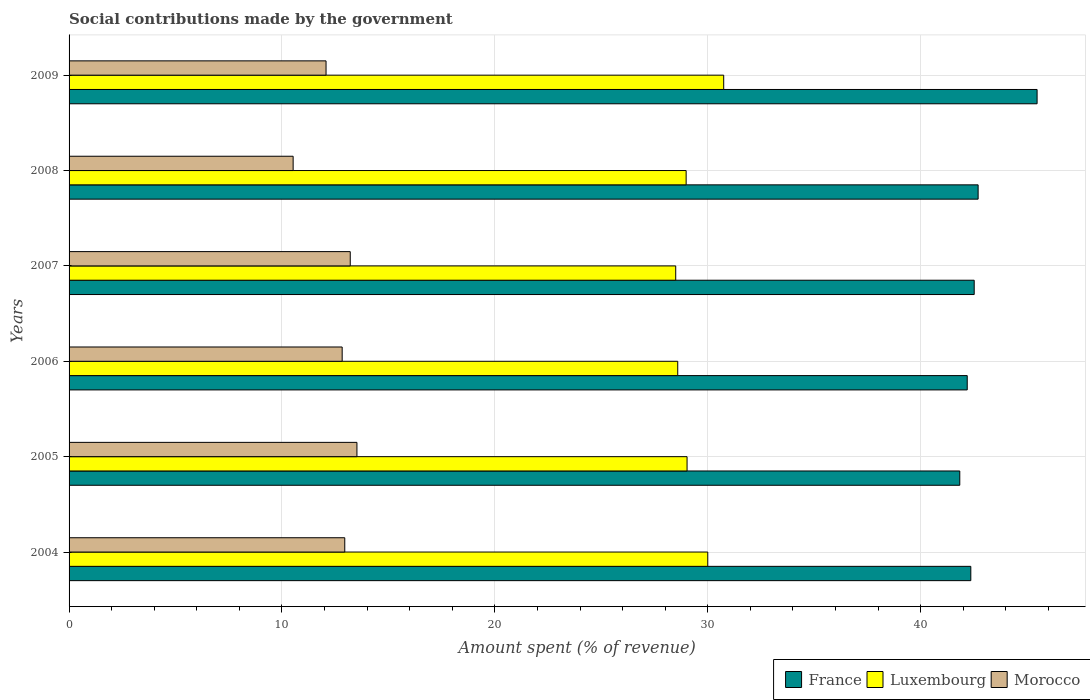How many groups of bars are there?
Offer a terse response. 6. How many bars are there on the 3rd tick from the top?
Make the answer very short. 3. What is the amount spent (in %) on social contributions in France in 2005?
Your answer should be very brief. 41.83. Across all years, what is the maximum amount spent (in %) on social contributions in Morocco?
Provide a short and direct response. 13.52. Across all years, what is the minimum amount spent (in %) on social contributions in Morocco?
Your response must be concise. 10.52. In which year was the amount spent (in %) on social contributions in Luxembourg maximum?
Provide a succinct answer. 2009. What is the total amount spent (in %) on social contributions in France in the graph?
Your answer should be compact. 257.04. What is the difference between the amount spent (in %) on social contributions in France in 2004 and that in 2009?
Ensure brevity in your answer.  -3.11. What is the difference between the amount spent (in %) on social contributions in Luxembourg in 2005 and the amount spent (in %) on social contributions in France in 2008?
Give a very brief answer. -13.67. What is the average amount spent (in %) on social contributions in Luxembourg per year?
Your response must be concise. 29.3. In the year 2006, what is the difference between the amount spent (in %) on social contributions in France and amount spent (in %) on social contributions in Morocco?
Offer a very short reply. 29.36. In how many years, is the amount spent (in %) on social contributions in France greater than 24 %?
Your answer should be compact. 6. What is the ratio of the amount spent (in %) on social contributions in Luxembourg in 2006 to that in 2008?
Offer a terse response. 0.99. Is the difference between the amount spent (in %) on social contributions in France in 2004 and 2008 greater than the difference between the amount spent (in %) on social contributions in Morocco in 2004 and 2008?
Your answer should be very brief. No. What is the difference between the highest and the second highest amount spent (in %) on social contributions in Morocco?
Your answer should be very brief. 0.31. What is the difference between the highest and the lowest amount spent (in %) on social contributions in France?
Ensure brevity in your answer.  3.63. In how many years, is the amount spent (in %) on social contributions in Luxembourg greater than the average amount spent (in %) on social contributions in Luxembourg taken over all years?
Provide a succinct answer. 2. What does the 3rd bar from the top in 2007 represents?
Make the answer very short. France. Are all the bars in the graph horizontal?
Keep it short and to the point. Yes. How many years are there in the graph?
Ensure brevity in your answer.  6. Are the values on the major ticks of X-axis written in scientific E-notation?
Your response must be concise. No. Does the graph contain grids?
Provide a succinct answer. Yes. How many legend labels are there?
Make the answer very short. 3. What is the title of the graph?
Offer a very short reply. Social contributions made by the government. What is the label or title of the X-axis?
Your answer should be very brief. Amount spent (% of revenue). What is the label or title of the Y-axis?
Keep it short and to the point. Years. What is the Amount spent (% of revenue) of France in 2004?
Your response must be concise. 42.35. What is the Amount spent (% of revenue) in Luxembourg in 2004?
Your response must be concise. 30. What is the Amount spent (% of revenue) of Morocco in 2004?
Ensure brevity in your answer.  12.95. What is the Amount spent (% of revenue) of France in 2005?
Your answer should be very brief. 41.83. What is the Amount spent (% of revenue) in Luxembourg in 2005?
Keep it short and to the point. 29.03. What is the Amount spent (% of revenue) in Morocco in 2005?
Give a very brief answer. 13.52. What is the Amount spent (% of revenue) in France in 2006?
Your response must be concise. 42.18. What is the Amount spent (% of revenue) in Luxembourg in 2006?
Your answer should be compact. 28.59. What is the Amount spent (% of revenue) in Morocco in 2006?
Offer a very short reply. 12.83. What is the Amount spent (% of revenue) in France in 2007?
Offer a terse response. 42.51. What is the Amount spent (% of revenue) of Luxembourg in 2007?
Give a very brief answer. 28.49. What is the Amount spent (% of revenue) of Morocco in 2007?
Your answer should be very brief. 13.21. What is the Amount spent (% of revenue) in France in 2008?
Your response must be concise. 42.7. What is the Amount spent (% of revenue) of Luxembourg in 2008?
Keep it short and to the point. 28.98. What is the Amount spent (% of revenue) in Morocco in 2008?
Ensure brevity in your answer.  10.52. What is the Amount spent (% of revenue) of France in 2009?
Provide a succinct answer. 45.46. What is the Amount spent (% of revenue) of Luxembourg in 2009?
Offer a terse response. 30.75. What is the Amount spent (% of revenue) in Morocco in 2009?
Keep it short and to the point. 12.07. Across all years, what is the maximum Amount spent (% of revenue) of France?
Give a very brief answer. 45.46. Across all years, what is the maximum Amount spent (% of revenue) in Luxembourg?
Give a very brief answer. 30.75. Across all years, what is the maximum Amount spent (% of revenue) of Morocco?
Offer a terse response. 13.52. Across all years, what is the minimum Amount spent (% of revenue) of France?
Offer a very short reply. 41.83. Across all years, what is the minimum Amount spent (% of revenue) of Luxembourg?
Offer a very short reply. 28.49. Across all years, what is the minimum Amount spent (% of revenue) of Morocco?
Your response must be concise. 10.52. What is the total Amount spent (% of revenue) in France in the graph?
Ensure brevity in your answer.  257.04. What is the total Amount spent (% of revenue) of Luxembourg in the graph?
Your answer should be very brief. 175.83. What is the total Amount spent (% of revenue) of Morocco in the graph?
Provide a short and direct response. 75.09. What is the difference between the Amount spent (% of revenue) of France in 2004 and that in 2005?
Keep it short and to the point. 0.52. What is the difference between the Amount spent (% of revenue) in Morocco in 2004 and that in 2005?
Provide a short and direct response. -0.57. What is the difference between the Amount spent (% of revenue) in France in 2004 and that in 2006?
Your response must be concise. 0.17. What is the difference between the Amount spent (% of revenue) in Luxembourg in 2004 and that in 2006?
Your answer should be very brief. 1.41. What is the difference between the Amount spent (% of revenue) in Morocco in 2004 and that in 2006?
Ensure brevity in your answer.  0.12. What is the difference between the Amount spent (% of revenue) in France in 2004 and that in 2007?
Make the answer very short. -0.16. What is the difference between the Amount spent (% of revenue) of Luxembourg in 2004 and that in 2007?
Your response must be concise. 1.5. What is the difference between the Amount spent (% of revenue) of Morocco in 2004 and that in 2007?
Offer a very short reply. -0.26. What is the difference between the Amount spent (% of revenue) of France in 2004 and that in 2008?
Your answer should be very brief. -0.34. What is the difference between the Amount spent (% of revenue) of Luxembourg in 2004 and that in 2008?
Offer a terse response. 1.02. What is the difference between the Amount spent (% of revenue) in Morocco in 2004 and that in 2008?
Offer a very short reply. 2.42. What is the difference between the Amount spent (% of revenue) of France in 2004 and that in 2009?
Ensure brevity in your answer.  -3.11. What is the difference between the Amount spent (% of revenue) of Luxembourg in 2004 and that in 2009?
Provide a short and direct response. -0.75. What is the difference between the Amount spent (% of revenue) of Morocco in 2004 and that in 2009?
Offer a terse response. 0.88. What is the difference between the Amount spent (% of revenue) in France in 2005 and that in 2006?
Your response must be concise. -0.35. What is the difference between the Amount spent (% of revenue) in Luxembourg in 2005 and that in 2006?
Offer a very short reply. 0.44. What is the difference between the Amount spent (% of revenue) of Morocco in 2005 and that in 2006?
Offer a terse response. 0.69. What is the difference between the Amount spent (% of revenue) of France in 2005 and that in 2007?
Your response must be concise. -0.68. What is the difference between the Amount spent (% of revenue) of Luxembourg in 2005 and that in 2007?
Your answer should be very brief. 0.53. What is the difference between the Amount spent (% of revenue) in Morocco in 2005 and that in 2007?
Keep it short and to the point. 0.31. What is the difference between the Amount spent (% of revenue) in France in 2005 and that in 2008?
Provide a succinct answer. -0.86. What is the difference between the Amount spent (% of revenue) of Luxembourg in 2005 and that in 2008?
Ensure brevity in your answer.  0.04. What is the difference between the Amount spent (% of revenue) in Morocco in 2005 and that in 2008?
Provide a short and direct response. 3. What is the difference between the Amount spent (% of revenue) in France in 2005 and that in 2009?
Provide a short and direct response. -3.63. What is the difference between the Amount spent (% of revenue) of Luxembourg in 2005 and that in 2009?
Your answer should be compact. -1.72. What is the difference between the Amount spent (% of revenue) in Morocco in 2005 and that in 2009?
Keep it short and to the point. 1.45. What is the difference between the Amount spent (% of revenue) of France in 2006 and that in 2007?
Offer a very short reply. -0.33. What is the difference between the Amount spent (% of revenue) of Luxembourg in 2006 and that in 2007?
Give a very brief answer. 0.09. What is the difference between the Amount spent (% of revenue) in Morocco in 2006 and that in 2007?
Give a very brief answer. -0.38. What is the difference between the Amount spent (% of revenue) of France in 2006 and that in 2008?
Make the answer very short. -0.51. What is the difference between the Amount spent (% of revenue) in Luxembourg in 2006 and that in 2008?
Offer a terse response. -0.4. What is the difference between the Amount spent (% of revenue) in Morocco in 2006 and that in 2008?
Provide a short and direct response. 2.3. What is the difference between the Amount spent (% of revenue) in France in 2006 and that in 2009?
Your response must be concise. -3.28. What is the difference between the Amount spent (% of revenue) in Luxembourg in 2006 and that in 2009?
Ensure brevity in your answer.  -2.16. What is the difference between the Amount spent (% of revenue) in Morocco in 2006 and that in 2009?
Ensure brevity in your answer.  0.76. What is the difference between the Amount spent (% of revenue) of France in 2007 and that in 2008?
Keep it short and to the point. -0.18. What is the difference between the Amount spent (% of revenue) of Luxembourg in 2007 and that in 2008?
Your answer should be very brief. -0.49. What is the difference between the Amount spent (% of revenue) in Morocco in 2007 and that in 2008?
Offer a very short reply. 2.68. What is the difference between the Amount spent (% of revenue) in France in 2007 and that in 2009?
Give a very brief answer. -2.95. What is the difference between the Amount spent (% of revenue) of Luxembourg in 2007 and that in 2009?
Make the answer very short. -2.25. What is the difference between the Amount spent (% of revenue) of Morocco in 2007 and that in 2009?
Ensure brevity in your answer.  1.14. What is the difference between the Amount spent (% of revenue) of France in 2008 and that in 2009?
Your response must be concise. -2.77. What is the difference between the Amount spent (% of revenue) in Luxembourg in 2008 and that in 2009?
Your response must be concise. -1.76. What is the difference between the Amount spent (% of revenue) in Morocco in 2008 and that in 2009?
Ensure brevity in your answer.  -1.55. What is the difference between the Amount spent (% of revenue) in France in 2004 and the Amount spent (% of revenue) in Luxembourg in 2005?
Keep it short and to the point. 13.33. What is the difference between the Amount spent (% of revenue) of France in 2004 and the Amount spent (% of revenue) of Morocco in 2005?
Ensure brevity in your answer.  28.83. What is the difference between the Amount spent (% of revenue) in Luxembourg in 2004 and the Amount spent (% of revenue) in Morocco in 2005?
Keep it short and to the point. 16.48. What is the difference between the Amount spent (% of revenue) of France in 2004 and the Amount spent (% of revenue) of Luxembourg in 2006?
Make the answer very short. 13.77. What is the difference between the Amount spent (% of revenue) of France in 2004 and the Amount spent (% of revenue) of Morocco in 2006?
Your answer should be compact. 29.52. What is the difference between the Amount spent (% of revenue) in Luxembourg in 2004 and the Amount spent (% of revenue) in Morocco in 2006?
Keep it short and to the point. 17.17. What is the difference between the Amount spent (% of revenue) of France in 2004 and the Amount spent (% of revenue) of Luxembourg in 2007?
Offer a very short reply. 13.86. What is the difference between the Amount spent (% of revenue) in France in 2004 and the Amount spent (% of revenue) in Morocco in 2007?
Ensure brevity in your answer.  29.15. What is the difference between the Amount spent (% of revenue) of Luxembourg in 2004 and the Amount spent (% of revenue) of Morocco in 2007?
Your response must be concise. 16.79. What is the difference between the Amount spent (% of revenue) in France in 2004 and the Amount spent (% of revenue) in Luxembourg in 2008?
Provide a succinct answer. 13.37. What is the difference between the Amount spent (% of revenue) of France in 2004 and the Amount spent (% of revenue) of Morocco in 2008?
Give a very brief answer. 31.83. What is the difference between the Amount spent (% of revenue) in Luxembourg in 2004 and the Amount spent (% of revenue) in Morocco in 2008?
Provide a short and direct response. 19.47. What is the difference between the Amount spent (% of revenue) of France in 2004 and the Amount spent (% of revenue) of Luxembourg in 2009?
Give a very brief answer. 11.61. What is the difference between the Amount spent (% of revenue) in France in 2004 and the Amount spent (% of revenue) in Morocco in 2009?
Offer a very short reply. 30.28. What is the difference between the Amount spent (% of revenue) in Luxembourg in 2004 and the Amount spent (% of revenue) in Morocco in 2009?
Provide a succinct answer. 17.93. What is the difference between the Amount spent (% of revenue) of France in 2005 and the Amount spent (% of revenue) of Luxembourg in 2006?
Offer a terse response. 13.25. What is the difference between the Amount spent (% of revenue) in France in 2005 and the Amount spent (% of revenue) in Morocco in 2006?
Your response must be concise. 29.01. What is the difference between the Amount spent (% of revenue) of Luxembourg in 2005 and the Amount spent (% of revenue) of Morocco in 2006?
Keep it short and to the point. 16.2. What is the difference between the Amount spent (% of revenue) in France in 2005 and the Amount spent (% of revenue) in Luxembourg in 2007?
Provide a short and direct response. 13.34. What is the difference between the Amount spent (% of revenue) of France in 2005 and the Amount spent (% of revenue) of Morocco in 2007?
Offer a terse response. 28.63. What is the difference between the Amount spent (% of revenue) of Luxembourg in 2005 and the Amount spent (% of revenue) of Morocco in 2007?
Offer a terse response. 15.82. What is the difference between the Amount spent (% of revenue) of France in 2005 and the Amount spent (% of revenue) of Luxembourg in 2008?
Provide a short and direct response. 12.85. What is the difference between the Amount spent (% of revenue) of France in 2005 and the Amount spent (% of revenue) of Morocco in 2008?
Provide a short and direct response. 31.31. What is the difference between the Amount spent (% of revenue) in Luxembourg in 2005 and the Amount spent (% of revenue) in Morocco in 2008?
Your answer should be very brief. 18.5. What is the difference between the Amount spent (% of revenue) of France in 2005 and the Amount spent (% of revenue) of Luxembourg in 2009?
Keep it short and to the point. 11.09. What is the difference between the Amount spent (% of revenue) of France in 2005 and the Amount spent (% of revenue) of Morocco in 2009?
Offer a very short reply. 29.76. What is the difference between the Amount spent (% of revenue) in Luxembourg in 2005 and the Amount spent (% of revenue) in Morocco in 2009?
Provide a succinct answer. 16.96. What is the difference between the Amount spent (% of revenue) of France in 2006 and the Amount spent (% of revenue) of Luxembourg in 2007?
Your response must be concise. 13.69. What is the difference between the Amount spent (% of revenue) of France in 2006 and the Amount spent (% of revenue) of Morocco in 2007?
Give a very brief answer. 28.98. What is the difference between the Amount spent (% of revenue) of Luxembourg in 2006 and the Amount spent (% of revenue) of Morocco in 2007?
Your answer should be very brief. 15.38. What is the difference between the Amount spent (% of revenue) in France in 2006 and the Amount spent (% of revenue) in Luxembourg in 2008?
Offer a very short reply. 13.2. What is the difference between the Amount spent (% of revenue) in France in 2006 and the Amount spent (% of revenue) in Morocco in 2008?
Provide a succinct answer. 31.66. What is the difference between the Amount spent (% of revenue) in Luxembourg in 2006 and the Amount spent (% of revenue) in Morocco in 2008?
Provide a short and direct response. 18.06. What is the difference between the Amount spent (% of revenue) of France in 2006 and the Amount spent (% of revenue) of Luxembourg in 2009?
Keep it short and to the point. 11.44. What is the difference between the Amount spent (% of revenue) of France in 2006 and the Amount spent (% of revenue) of Morocco in 2009?
Ensure brevity in your answer.  30.11. What is the difference between the Amount spent (% of revenue) in Luxembourg in 2006 and the Amount spent (% of revenue) in Morocco in 2009?
Give a very brief answer. 16.52. What is the difference between the Amount spent (% of revenue) of France in 2007 and the Amount spent (% of revenue) of Luxembourg in 2008?
Keep it short and to the point. 13.53. What is the difference between the Amount spent (% of revenue) of France in 2007 and the Amount spent (% of revenue) of Morocco in 2008?
Your answer should be compact. 31.99. What is the difference between the Amount spent (% of revenue) of Luxembourg in 2007 and the Amount spent (% of revenue) of Morocco in 2008?
Make the answer very short. 17.97. What is the difference between the Amount spent (% of revenue) of France in 2007 and the Amount spent (% of revenue) of Luxembourg in 2009?
Make the answer very short. 11.76. What is the difference between the Amount spent (% of revenue) of France in 2007 and the Amount spent (% of revenue) of Morocco in 2009?
Keep it short and to the point. 30.44. What is the difference between the Amount spent (% of revenue) in Luxembourg in 2007 and the Amount spent (% of revenue) in Morocco in 2009?
Offer a terse response. 16.42. What is the difference between the Amount spent (% of revenue) in France in 2008 and the Amount spent (% of revenue) in Luxembourg in 2009?
Your response must be concise. 11.95. What is the difference between the Amount spent (% of revenue) in France in 2008 and the Amount spent (% of revenue) in Morocco in 2009?
Provide a short and direct response. 30.63. What is the difference between the Amount spent (% of revenue) in Luxembourg in 2008 and the Amount spent (% of revenue) in Morocco in 2009?
Your answer should be very brief. 16.91. What is the average Amount spent (% of revenue) in France per year?
Your answer should be very brief. 42.84. What is the average Amount spent (% of revenue) of Luxembourg per year?
Your answer should be compact. 29.3. What is the average Amount spent (% of revenue) in Morocco per year?
Keep it short and to the point. 12.52. In the year 2004, what is the difference between the Amount spent (% of revenue) in France and Amount spent (% of revenue) in Luxembourg?
Offer a very short reply. 12.35. In the year 2004, what is the difference between the Amount spent (% of revenue) of France and Amount spent (% of revenue) of Morocco?
Your answer should be very brief. 29.4. In the year 2004, what is the difference between the Amount spent (% of revenue) in Luxembourg and Amount spent (% of revenue) in Morocco?
Offer a terse response. 17.05. In the year 2005, what is the difference between the Amount spent (% of revenue) in France and Amount spent (% of revenue) in Luxembourg?
Keep it short and to the point. 12.81. In the year 2005, what is the difference between the Amount spent (% of revenue) in France and Amount spent (% of revenue) in Morocco?
Ensure brevity in your answer.  28.31. In the year 2005, what is the difference between the Amount spent (% of revenue) of Luxembourg and Amount spent (% of revenue) of Morocco?
Offer a terse response. 15.51. In the year 2006, what is the difference between the Amount spent (% of revenue) in France and Amount spent (% of revenue) in Luxembourg?
Keep it short and to the point. 13.6. In the year 2006, what is the difference between the Amount spent (% of revenue) in France and Amount spent (% of revenue) in Morocco?
Give a very brief answer. 29.36. In the year 2006, what is the difference between the Amount spent (% of revenue) of Luxembourg and Amount spent (% of revenue) of Morocco?
Offer a very short reply. 15.76. In the year 2007, what is the difference between the Amount spent (% of revenue) in France and Amount spent (% of revenue) in Luxembourg?
Your answer should be compact. 14.02. In the year 2007, what is the difference between the Amount spent (% of revenue) in France and Amount spent (% of revenue) in Morocco?
Provide a succinct answer. 29.3. In the year 2007, what is the difference between the Amount spent (% of revenue) in Luxembourg and Amount spent (% of revenue) in Morocco?
Ensure brevity in your answer.  15.29. In the year 2008, what is the difference between the Amount spent (% of revenue) of France and Amount spent (% of revenue) of Luxembourg?
Offer a terse response. 13.71. In the year 2008, what is the difference between the Amount spent (% of revenue) of France and Amount spent (% of revenue) of Morocco?
Your answer should be very brief. 32.17. In the year 2008, what is the difference between the Amount spent (% of revenue) in Luxembourg and Amount spent (% of revenue) in Morocco?
Your response must be concise. 18.46. In the year 2009, what is the difference between the Amount spent (% of revenue) of France and Amount spent (% of revenue) of Luxembourg?
Offer a very short reply. 14.72. In the year 2009, what is the difference between the Amount spent (% of revenue) of France and Amount spent (% of revenue) of Morocco?
Keep it short and to the point. 33.4. In the year 2009, what is the difference between the Amount spent (% of revenue) of Luxembourg and Amount spent (% of revenue) of Morocco?
Provide a succinct answer. 18.68. What is the ratio of the Amount spent (% of revenue) in France in 2004 to that in 2005?
Make the answer very short. 1.01. What is the ratio of the Amount spent (% of revenue) of Luxembourg in 2004 to that in 2005?
Your answer should be compact. 1.03. What is the ratio of the Amount spent (% of revenue) of Morocco in 2004 to that in 2005?
Make the answer very short. 0.96. What is the ratio of the Amount spent (% of revenue) of France in 2004 to that in 2006?
Your answer should be compact. 1. What is the ratio of the Amount spent (% of revenue) in Luxembourg in 2004 to that in 2006?
Offer a very short reply. 1.05. What is the ratio of the Amount spent (% of revenue) of Morocco in 2004 to that in 2006?
Provide a short and direct response. 1.01. What is the ratio of the Amount spent (% of revenue) in Luxembourg in 2004 to that in 2007?
Your answer should be compact. 1.05. What is the ratio of the Amount spent (% of revenue) in Morocco in 2004 to that in 2007?
Give a very brief answer. 0.98. What is the ratio of the Amount spent (% of revenue) in Luxembourg in 2004 to that in 2008?
Provide a short and direct response. 1.03. What is the ratio of the Amount spent (% of revenue) in Morocco in 2004 to that in 2008?
Provide a succinct answer. 1.23. What is the ratio of the Amount spent (% of revenue) in France in 2004 to that in 2009?
Offer a very short reply. 0.93. What is the ratio of the Amount spent (% of revenue) of Luxembourg in 2004 to that in 2009?
Your answer should be very brief. 0.98. What is the ratio of the Amount spent (% of revenue) in Morocco in 2004 to that in 2009?
Provide a succinct answer. 1.07. What is the ratio of the Amount spent (% of revenue) of France in 2005 to that in 2006?
Your response must be concise. 0.99. What is the ratio of the Amount spent (% of revenue) in Luxembourg in 2005 to that in 2006?
Offer a terse response. 1.02. What is the ratio of the Amount spent (% of revenue) of Morocco in 2005 to that in 2006?
Your response must be concise. 1.05. What is the ratio of the Amount spent (% of revenue) in France in 2005 to that in 2007?
Make the answer very short. 0.98. What is the ratio of the Amount spent (% of revenue) in Luxembourg in 2005 to that in 2007?
Your answer should be compact. 1.02. What is the ratio of the Amount spent (% of revenue) in Morocco in 2005 to that in 2007?
Give a very brief answer. 1.02. What is the ratio of the Amount spent (% of revenue) of France in 2005 to that in 2008?
Ensure brevity in your answer.  0.98. What is the ratio of the Amount spent (% of revenue) in Morocco in 2005 to that in 2008?
Provide a short and direct response. 1.28. What is the ratio of the Amount spent (% of revenue) in France in 2005 to that in 2009?
Your response must be concise. 0.92. What is the ratio of the Amount spent (% of revenue) of Luxembourg in 2005 to that in 2009?
Your answer should be compact. 0.94. What is the ratio of the Amount spent (% of revenue) in Morocco in 2005 to that in 2009?
Make the answer very short. 1.12. What is the ratio of the Amount spent (% of revenue) in France in 2006 to that in 2007?
Provide a succinct answer. 0.99. What is the ratio of the Amount spent (% of revenue) of Luxembourg in 2006 to that in 2007?
Offer a terse response. 1. What is the ratio of the Amount spent (% of revenue) in Morocco in 2006 to that in 2007?
Ensure brevity in your answer.  0.97. What is the ratio of the Amount spent (% of revenue) of Luxembourg in 2006 to that in 2008?
Give a very brief answer. 0.99. What is the ratio of the Amount spent (% of revenue) of Morocco in 2006 to that in 2008?
Offer a very short reply. 1.22. What is the ratio of the Amount spent (% of revenue) of France in 2006 to that in 2009?
Your response must be concise. 0.93. What is the ratio of the Amount spent (% of revenue) in Luxembourg in 2006 to that in 2009?
Your answer should be very brief. 0.93. What is the ratio of the Amount spent (% of revenue) in Morocco in 2006 to that in 2009?
Your response must be concise. 1.06. What is the ratio of the Amount spent (% of revenue) in France in 2007 to that in 2008?
Your response must be concise. 1. What is the ratio of the Amount spent (% of revenue) of Luxembourg in 2007 to that in 2008?
Your answer should be very brief. 0.98. What is the ratio of the Amount spent (% of revenue) in Morocco in 2007 to that in 2008?
Your answer should be compact. 1.25. What is the ratio of the Amount spent (% of revenue) of France in 2007 to that in 2009?
Provide a succinct answer. 0.94. What is the ratio of the Amount spent (% of revenue) in Luxembourg in 2007 to that in 2009?
Offer a terse response. 0.93. What is the ratio of the Amount spent (% of revenue) of Morocco in 2007 to that in 2009?
Give a very brief answer. 1.09. What is the ratio of the Amount spent (% of revenue) in France in 2008 to that in 2009?
Keep it short and to the point. 0.94. What is the ratio of the Amount spent (% of revenue) of Luxembourg in 2008 to that in 2009?
Give a very brief answer. 0.94. What is the ratio of the Amount spent (% of revenue) of Morocco in 2008 to that in 2009?
Ensure brevity in your answer.  0.87. What is the difference between the highest and the second highest Amount spent (% of revenue) of France?
Ensure brevity in your answer.  2.77. What is the difference between the highest and the second highest Amount spent (% of revenue) of Luxembourg?
Your answer should be compact. 0.75. What is the difference between the highest and the second highest Amount spent (% of revenue) of Morocco?
Your response must be concise. 0.31. What is the difference between the highest and the lowest Amount spent (% of revenue) in France?
Ensure brevity in your answer.  3.63. What is the difference between the highest and the lowest Amount spent (% of revenue) of Luxembourg?
Your answer should be compact. 2.25. What is the difference between the highest and the lowest Amount spent (% of revenue) of Morocco?
Your answer should be very brief. 3. 